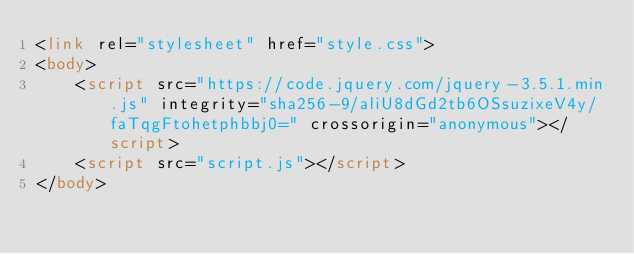<code> <loc_0><loc_0><loc_500><loc_500><_HTML_><link rel="stylesheet" href="style.css">
<body>
    <script src="https://code.jquery.com/jquery-3.5.1.min.js" integrity="sha256-9/aliU8dGd2tb6OSsuzixeV4y/faTqgFtohetphbbj0=" crossorigin="anonymous"></script>
    <script src="script.js"></script>
</body></code> 